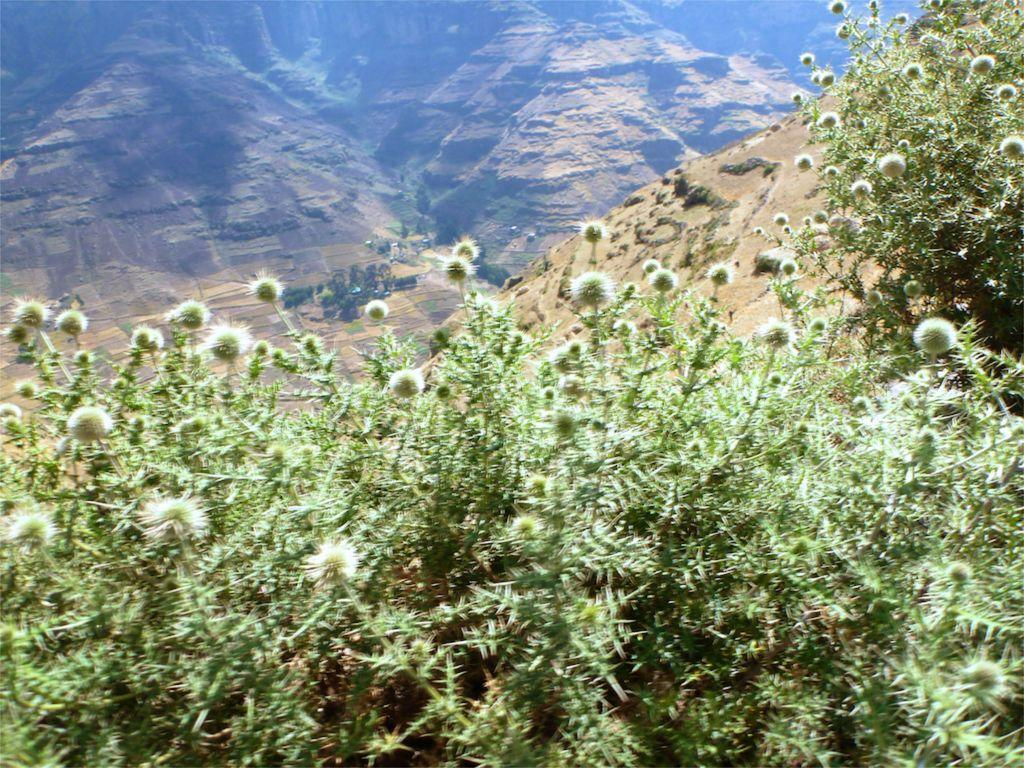What type of plants can be seen in the image? There are plants with flowers in the image. What natural feature is visible in the background of the image? There are mountains visible in the image. How many beetles can be seen crawling on the bushes in the image? There are no beetles present in the image, and the bushes are not mentioned in the provided facts. 